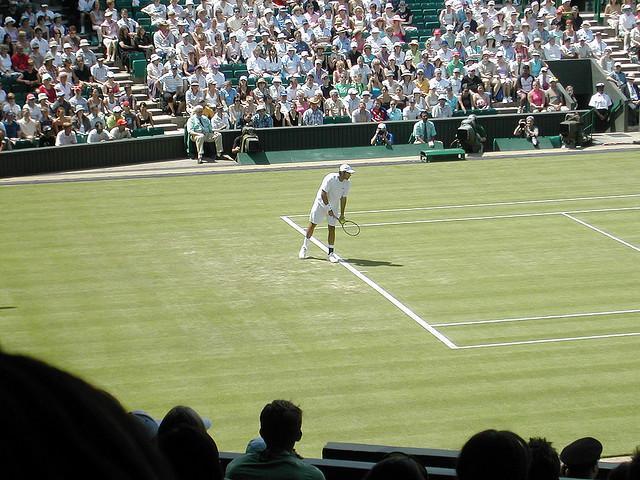How many people are in the photo?
Give a very brief answer. 4. 